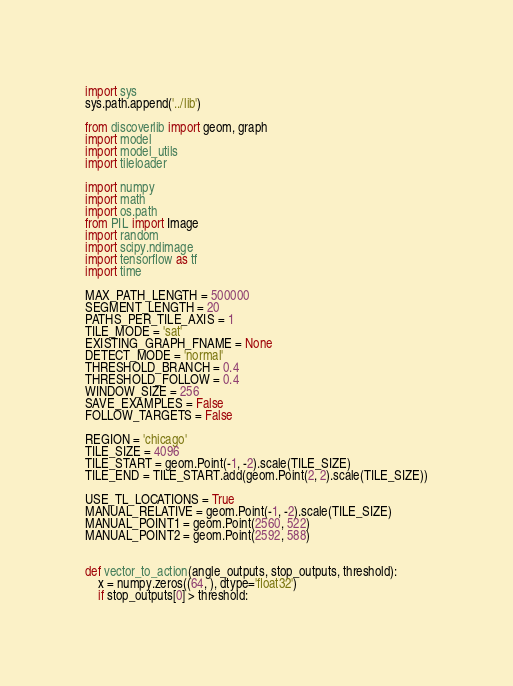<code> <loc_0><loc_0><loc_500><loc_500><_Python_>import sys
sys.path.append('../lib')

from discoverlib import geom, graph
import model
import model_utils
import tileloader

import numpy
import math
import os.path
from PIL import Image
import random
import scipy.ndimage
import tensorflow as tf
import time

MAX_PATH_LENGTH = 500000
SEGMENT_LENGTH = 20
PATHS_PER_TILE_AXIS = 1
TILE_MODE = 'sat'
EXISTING_GRAPH_FNAME = None
DETECT_MODE = 'normal'
THRESHOLD_BRANCH = 0.4
THRESHOLD_FOLLOW = 0.4
WINDOW_SIZE = 256
SAVE_EXAMPLES = False
FOLLOW_TARGETS = False

REGION = 'chicago'
TILE_SIZE = 4096
TILE_START = geom.Point(-1, -2).scale(TILE_SIZE)
TILE_END = TILE_START.add(geom.Point(2, 2).scale(TILE_SIZE))

USE_TL_LOCATIONS = True
MANUAL_RELATIVE = geom.Point(-1, -2).scale(TILE_SIZE)
MANUAL_POINT1 = geom.Point(2560, 522)
MANUAL_POINT2 = geom.Point(2592, 588)


def vector_to_action(angle_outputs, stop_outputs, threshold):
    x = numpy.zeros((64, ), dtype='float32')
    if stop_outputs[0] > threshold:</code> 